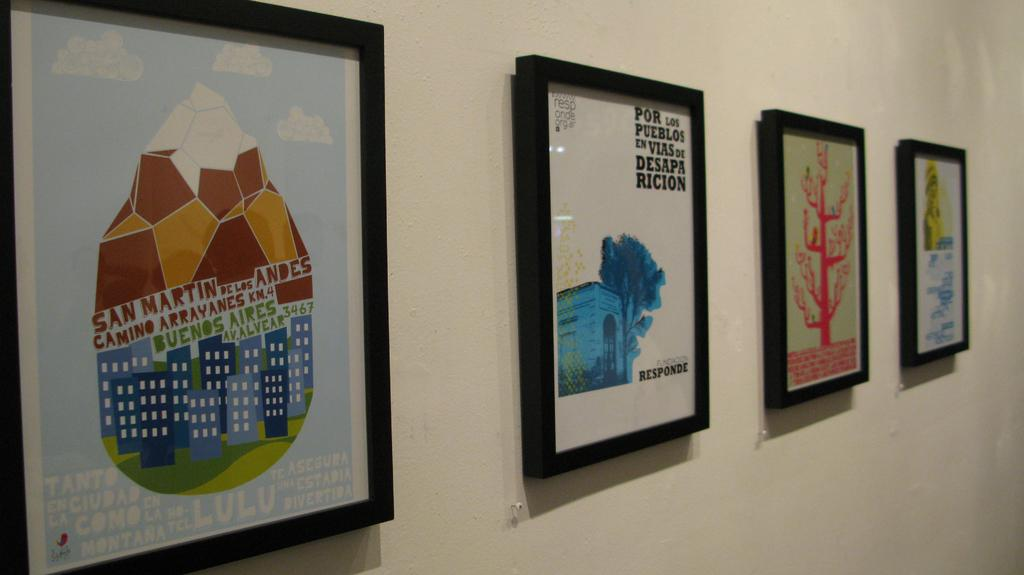<image>
Write a terse but informative summary of the picture. Framed art that says "por los pueblos en vias de desapa ricion" hangs with other art pieces on a wall. 